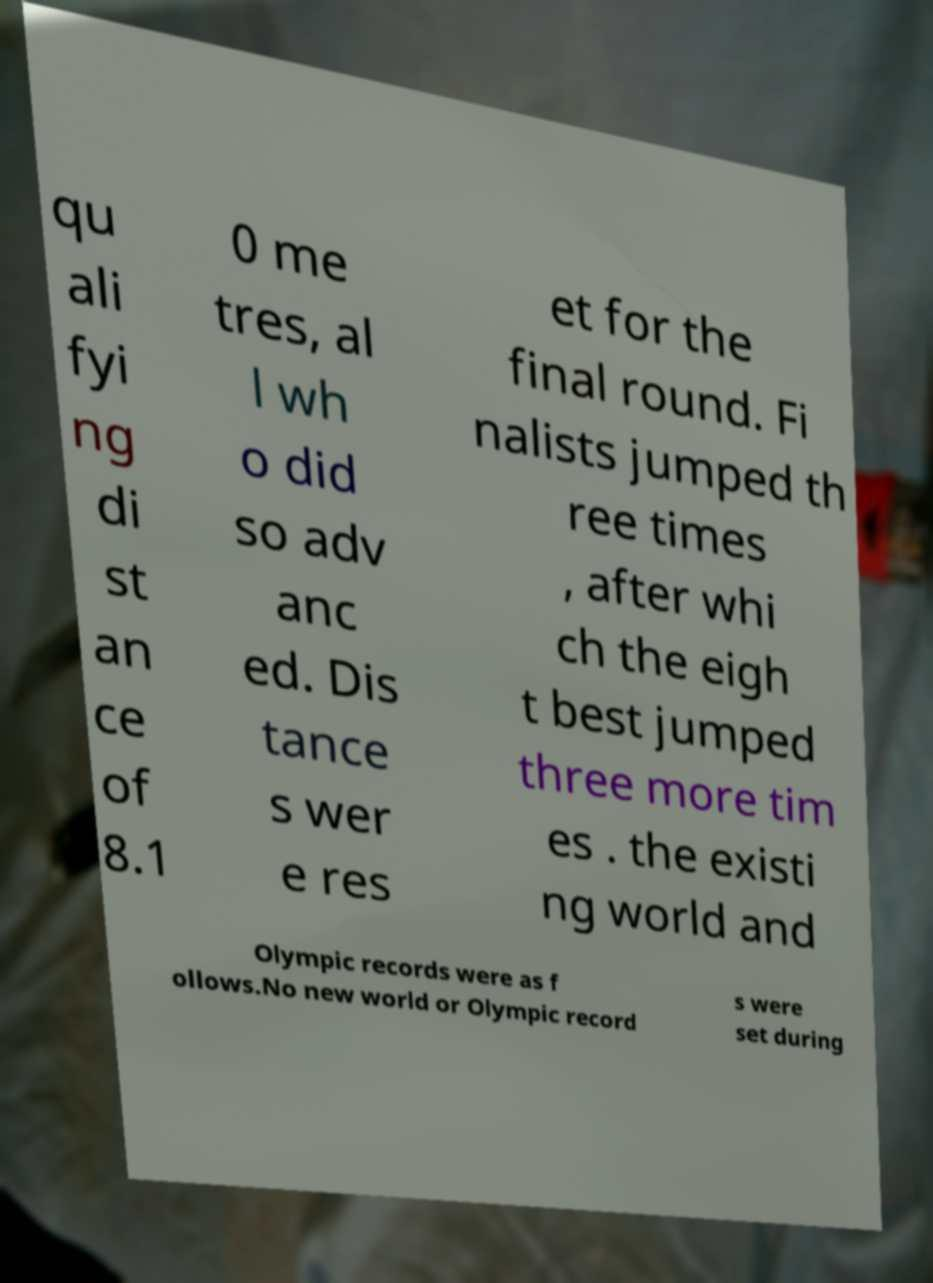Could you extract and type out the text from this image? qu ali fyi ng di st an ce of 8.1 0 me tres, al l wh o did so adv anc ed. Dis tance s wer e res et for the final round. Fi nalists jumped th ree times , after whi ch the eigh t best jumped three more tim es . the existi ng world and Olympic records were as f ollows.No new world or Olympic record s were set during 